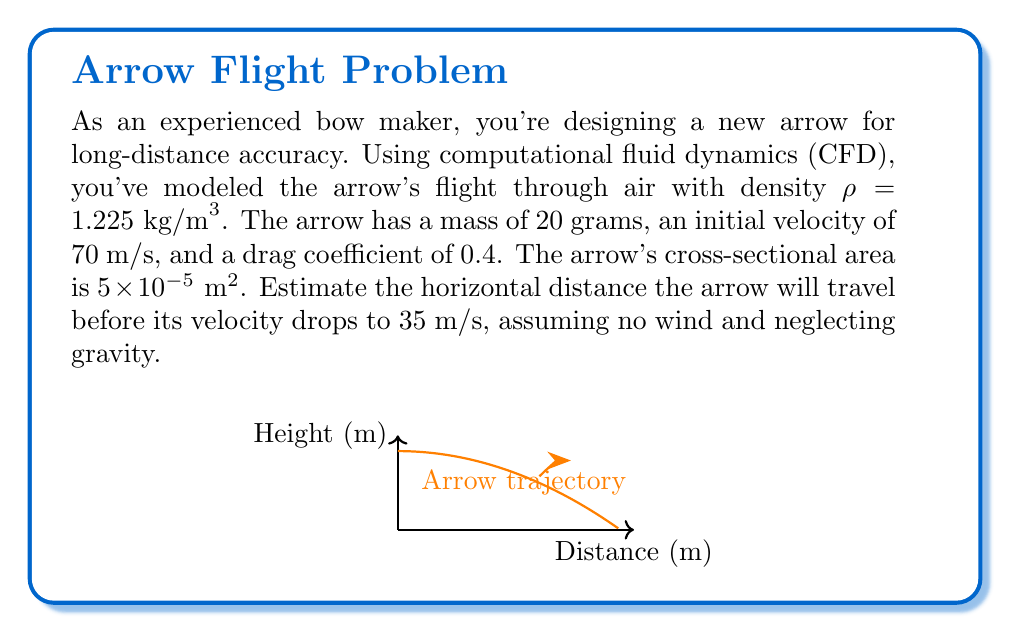Could you help me with this problem? To solve this problem, we'll use the principles of computational fluid dynamics and projectile motion:

1) The drag force on the arrow is given by:
   $$F_d = \frac{1}{2} \rho v^2 C_d A$$
   where ρ is air density, v is velocity, C_d is drag coefficient, and A is cross-sectional area.

2) The deceleration due to drag is:
   $$a = \frac{F_d}{m} = \frac{\rho v^2 C_d A}{2m}$$

3) We can express this as a differential equation:
   $$\frac{dv}{dt} = -\frac{\rho v^2 C_d A}{2m}$$

4) Separating variables and integrating:
   $$\int_{v_0}^{v} \frac{dv}{v^2} = -\int_0^t \frac{\rho C_d A}{2m} dt$$

5) Solving the integral:
   $$\frac{1}{v} - \frac{1}{v_0} = \frac{\rho C_d A}{2m} t$$

6) Rearranging to solve for t:
   $$t = \frac{2m}{\rho C_d A} (\frac{1}{v} - \frac{1}{v_0})$$

7) Substituting the given values:
   $$t = \frac{2(0.02)}{1.225(0.4)(5 \times 10^{-5})} (\frac{1}{35} - \frac{1}{70}) \approx 1.86 \text{ seconds}$$

8) The horizontal distance traveled is:
   $$x = v_{\text{avg}} \times t = \frac{70 + 35}{2} \times 1.86 \approx 97.65 \text{ meters}$$
Answer: 97.65 meters 